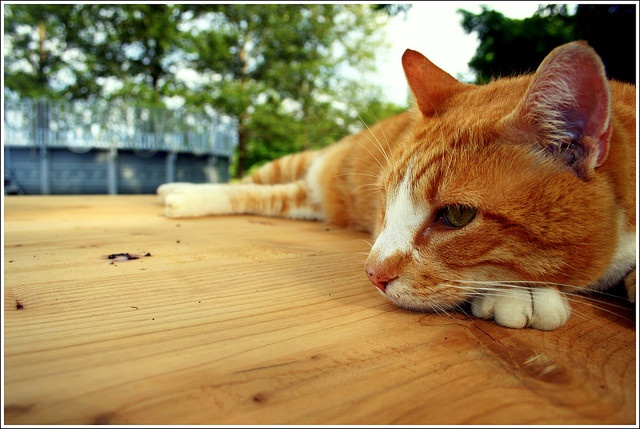Describe the objects in this image and their specific colors. I can see a cat in black, brown, maroon, and tan tones in this image. 